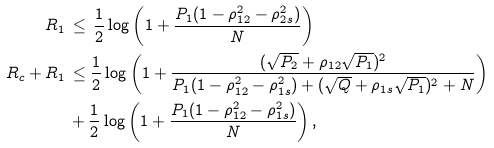<formula> <loc_0><loc_0><loc_500><loc_500>R _ { 1 } \, & \leq \, \frac { 1 } { 2 } \log \left ( 1 + \frac { P _ { 1 } ( 1 - \rho ^ { 2 } _ { 1 2 } - \rho ^ { 2 } _ { 2 s } ) } { N } \right ) \\ R _ { c } + R _ { 1 } \, & \leq \frac { 1 } { 2 } \log \left ( 1 + \frac { ( \sqrt { P _ { 2 } } + \rho _ { 1 2 } \sqrt { P _ { 1 } } ) ^ { 2 } } { P _ { 1 } ( 1 - \rho ^ { 2 } _ { 1 2 } - \rho ^ { 2 } _ { 1 s } ) + ( \sqrt { Q } + \rho _ { 1 s } \sqrt { P _ { 1 } } ) ^ { 2 } + N } \right ) \\ & + \frac { 1 } { 2 } \log \left ( 1 + \frac { P _ { 1 } ( 1 - \rho ^ { 2 } _ { 1 2 } - \rho ^ { 2 } _ { 1 s } ) } { N } \right ) ,</formula> 